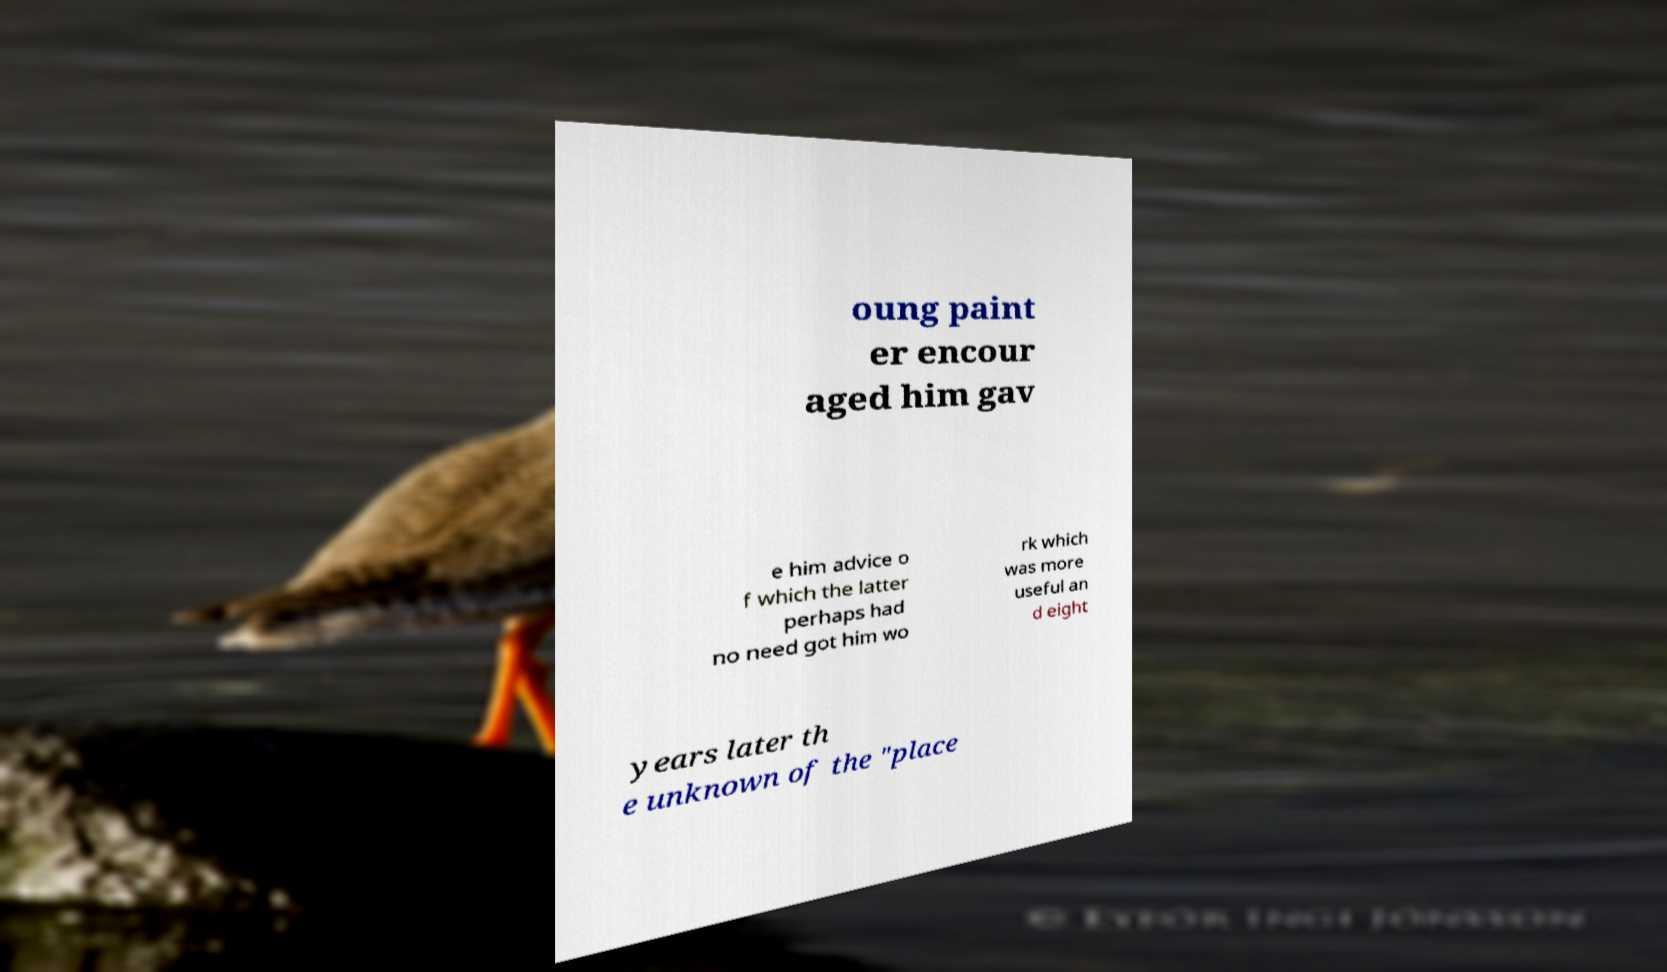I need the written content from this picture converted into text. Can you do that? oung paint er encour aged him gav e him advice o f which the latter perhaps had no need got him wo rk which was more useful an d eight years later th e unknown of the "place 